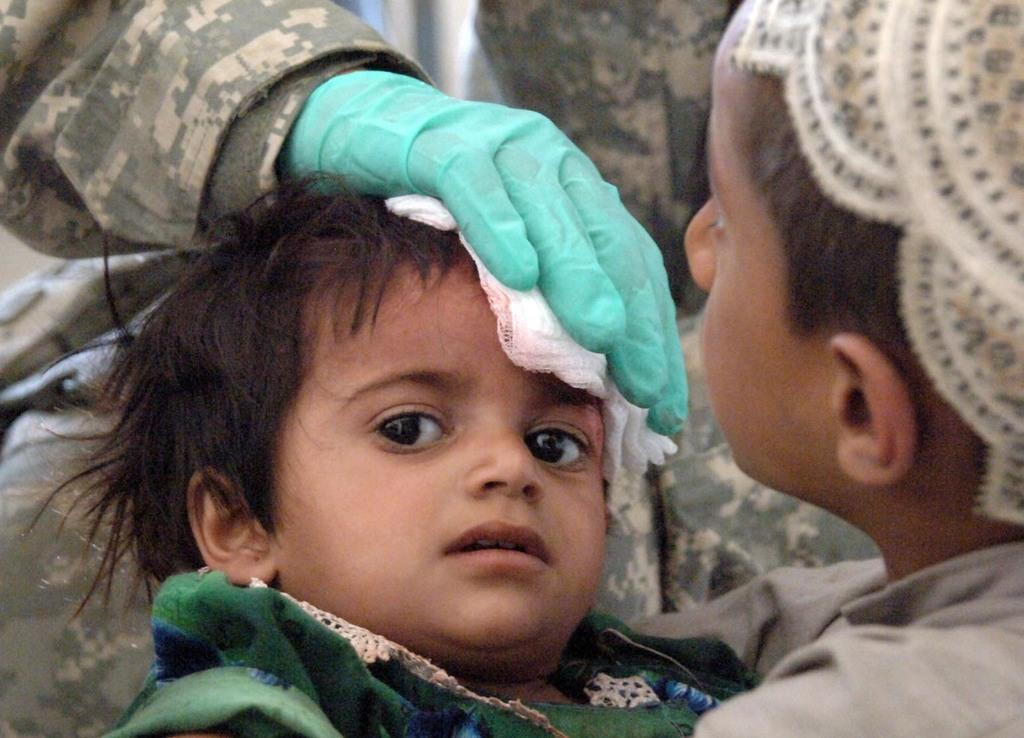Who is the main subject in the center of the image? There is a person in the center of the image. What is the person wearing? The person is wearing gloves. What is the person doing in the image? The person is putting a kerchief on a child. Can you identify the child in the image? Yes, there is a child in the image. Where is the boy located in the image? The boy is on the right side of the image. What type of whip can be seen in the image? There is no whip present in the image. Is there a cactus visible in the image? No, there is no cactus visible in the image. 